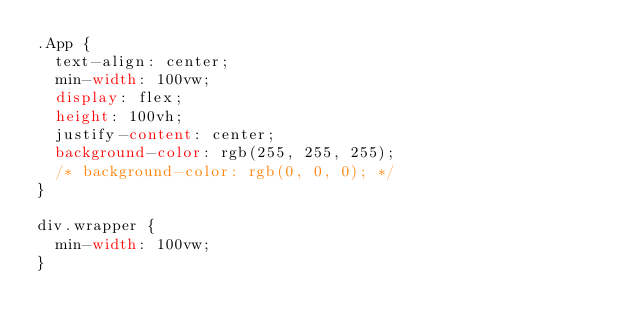<code> <loc_0><loc_0><loc_500><loc_500><_CSS_>.App {
  text-align: center;
  min-width: 100vw;
  display: flex;
  height: 100vh;
  justify-content: center;
  background-color: rgb(255, 255, 255);
  /* background-color: rgb(0, 0, 0); */
}

div.wrapper {
  min-width: 100vw;
}
</code> 